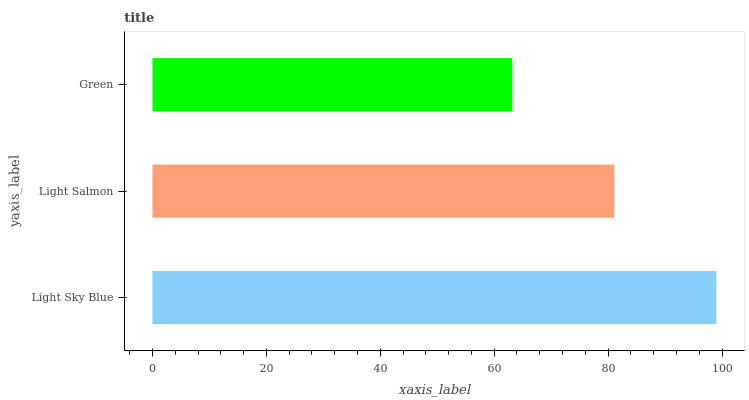Is Green the minimum?
Answer yes or no. Yes. Is Light Sky Blue the maximum?
Answer yes or no. Yes. Is Light Salmon the minimum?
Answer yes or no. No. Is Light Salmon the maximum?
Answer yes or no. No. Is Light Sky Blue greater than Light Salmon?
Answer yes or no. Yes. Is Light Salmon less than Light Sky Blue?
Answer yes or no. Yes. Is Light Salmon greater than Light Sky Blue?
Answer yes or no. No. Is Light Sky Blue less than Light Salmon?
Answer yes or no. No. Is Light Salmon the high median?
Answer yes or no. Yes. Is Light Salmon the low median?
Answer yes or no. Yes. Is Light Sky Blue the high median?
Answer yes or no. No. Is Light Sky Blue the low median?
Answer yes or no. No. 